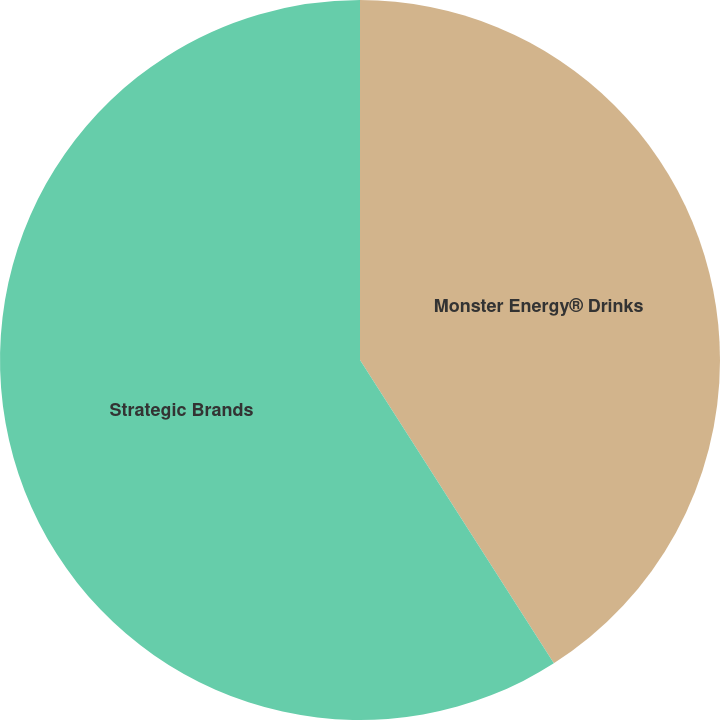Convert chart. <chart><loc_0><loc_0><loc_500><loc_500><pie_chart><fcel>Monster Energy® Drinks<fcel>Strategic Brands<nl><fcel>40.95%<fcel>59.05%<nl></chart> 